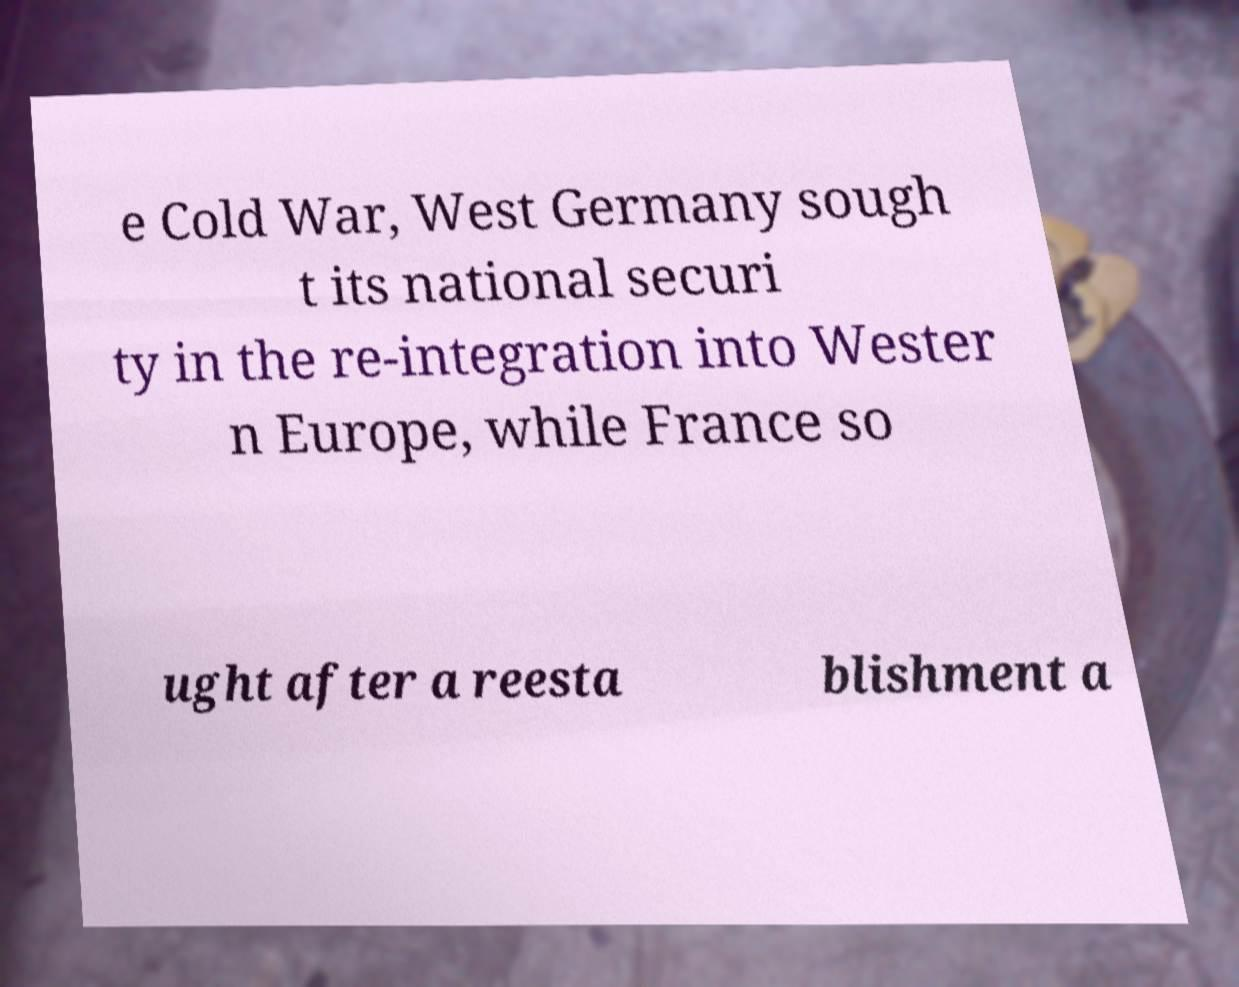I need the written content from this picture converted into text. Can you do that? e Cold War, West Germany sough t its national securi ty in the re-integration into Wester n Europe, while France so ught after a reesta blishment a 